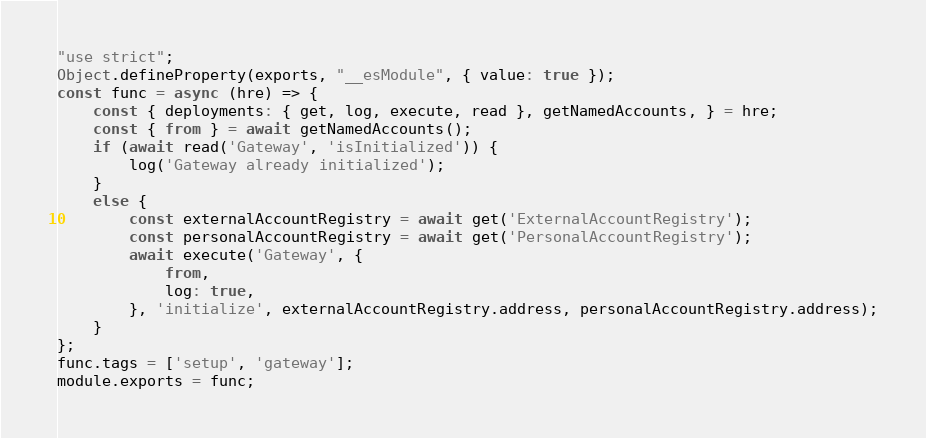<code> <loc_0><loc_0><loc_500><loc_500><_JavaScript_>"use strict";
Object.defineProperty(exports, "__esModule", { value: true });
const func = async (hre) => {
    const { deployments: { get, log, execute, read }, getNamedAccounts, } = hre;
    const { from } = await getNamedAccounts();
    if (await read('Gateway', 'isInitialized')) {
        log('Gateway already initialized');
    }
    else {
        const externalAccountRegistry = await get('ExternalAccountRegistry');
        const personalAccountRegistry = await get('PersonalAccountRegistry');
        await execute('Gateway', {
            from,
            log: true,
        }, 'initialize', externalAccountRegistry.address, personalAccountRegistry.address);
    }
};
func.tags = ['setup', 'gateway'];
module.exports = func;
</code> 